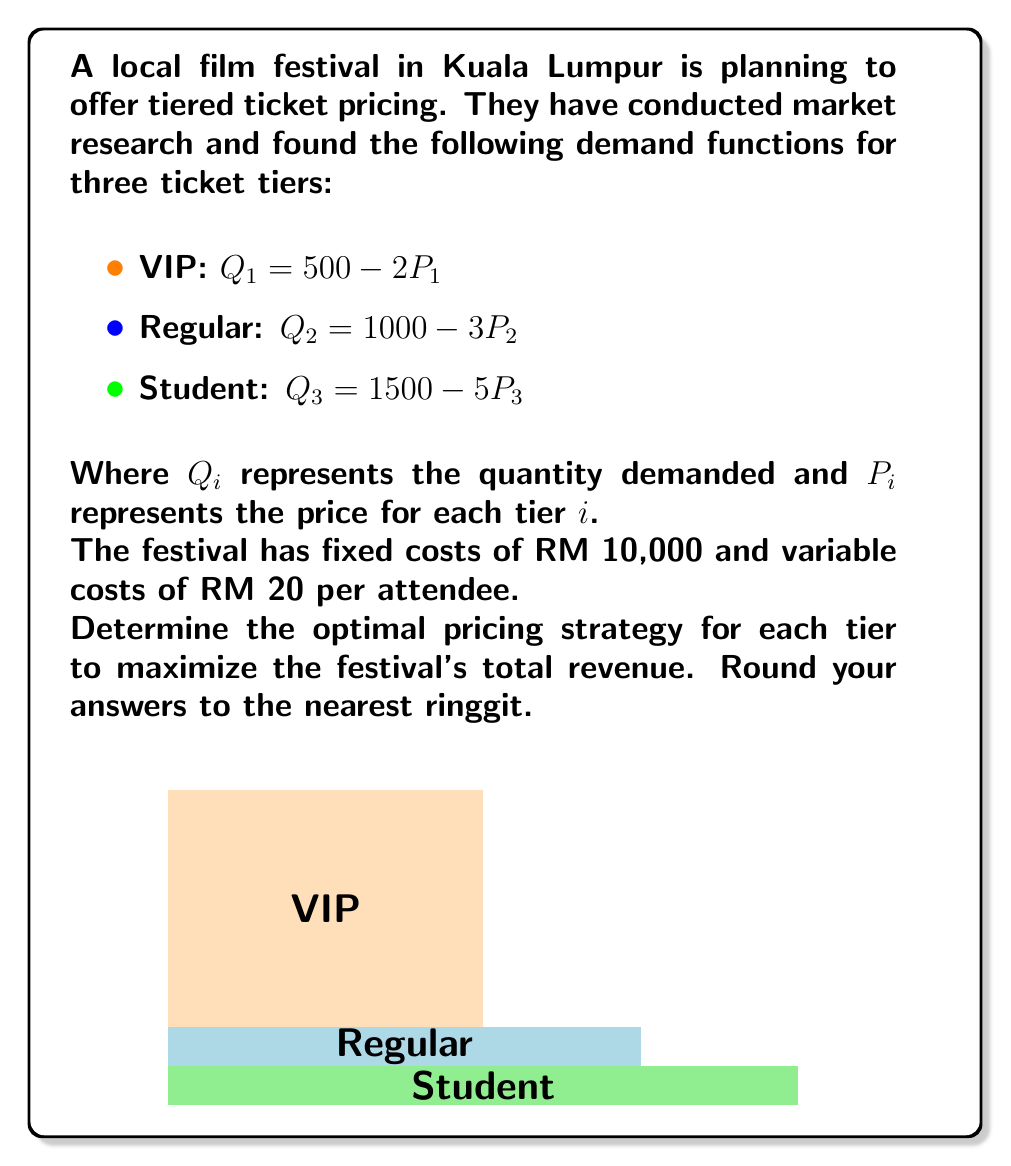Show me your answer to this math problem. Let's approach this step-by-step:

1) First, we need to find the revenue function for each tier. Revenue is price times quantity:

   $R_1 = P_1Q_1 = P_1(500 - 2P_1) = 500P_1 - 2P_1^2$
   $R_2 = P_2Q_2 = P_2(1000 - 3P_2) = 1000P_2 - 3P_2^2$
   $R_3 = P_3Q_3 = P_3(1500 - 5P_3) = 1500P_3 - 5P_3^2$

2) The total revenue function is the sum of these:

   $R_{total} = (500P_1 - 2P_1^2) + (1000P_2 - 3P_2^2) + (1500P_3 - 5P_3^2)$

3) To maximize revenue, we need to find the partial derivatives with respect to each price and set them to zero:

   $\frac{\partial R}{\partial P_1} = 500 - 4P_1 = 0$
   $\frac{\partial R}{\partial P_2} = 1000 - 6P_2 = 0$
   $\frac{\partial R}{\partial P_3} = 1500 - 10P_3 = 0$

4) Solving these equations:

   $P_1 = 125$
   $P_2 = 166.67$
   $P_3 = 150$

5) Rounding to the nearest ringgit:

   $P_1 = 125$ RM
   $P_2 = 167$ RM
   $P_3 = 150$ RM

6) To verify this is a maximum, we can check the second derivatives are negative:

   $\frac{\partial^2 R}{\partial P_1^2} = -4 < 0$
   $\frac{\partial^2 R}{\partial P_2^2} = -6 < 0$
   $\frac{\partial^2 R}{\partial P_3^2} = -10 < 0$

Therefore, these prices will maximize revenue.
Answer: VIP: 125 RM, Regular: 167 RM, Student: 150 RM 